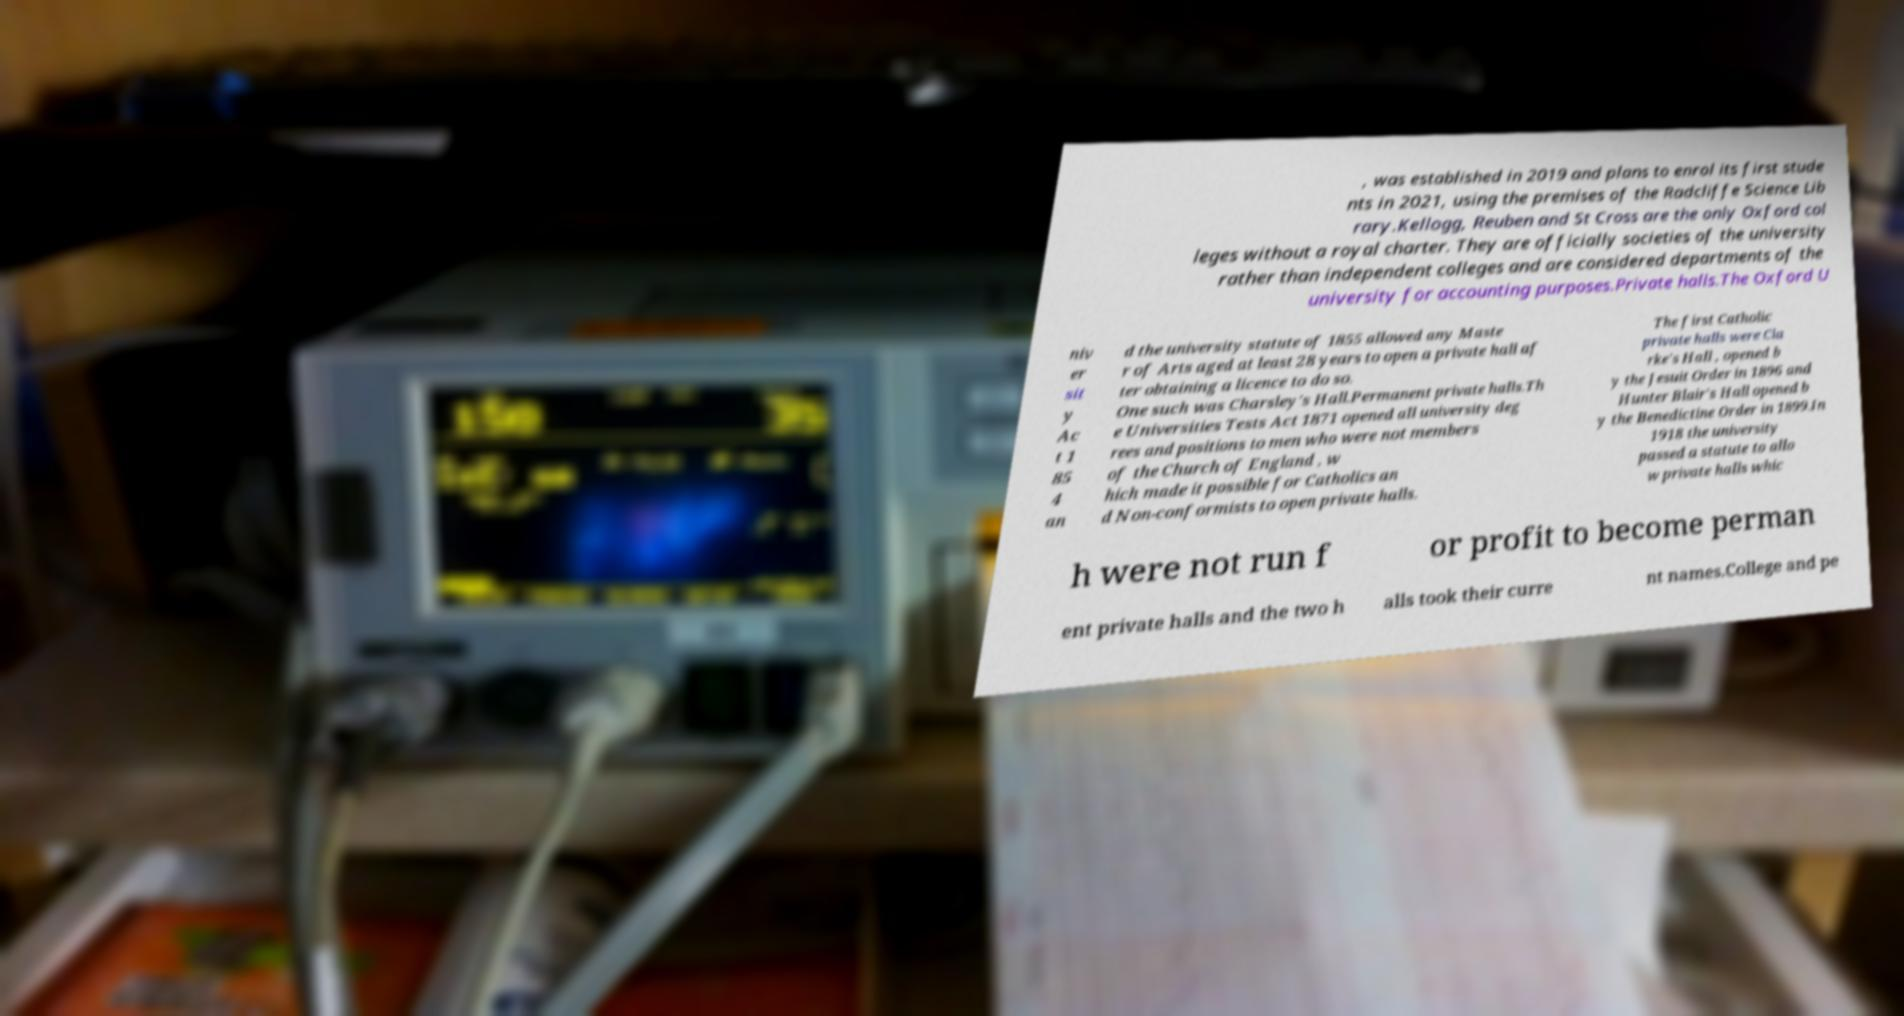Can you read and provide the text displayed in the image?This photo seems to have some interesting text. Can you extract and type it out for me? , was established in 2019 and plans to enrol its first stude nts in 2021, using the premises of the Radcliffe Science Lib rary.Kellogg, Reuben and St Cross are the only Oxford col leges without a royal charter. They are officially societies of the university rather than independent colleges and are considered departments of the university for accounting purposes.Private halls.The Oxford U niv er sit y Ac t 1 85 4 an d the university statute of 1855 allowed any Maste r of Arts aged at least 28 years to open a private hall af ter obtaining a licence to do so. One such was Charsley's Hall.Permanent private halls.Th e Universities Tests Act 1871 opened all university deg rees and positions to men who were not members of the Church of England , w hich made it possible for Catholics an d Non-conformists to open private halls. The first Catholic private halls were Cla rke's Hall , opened b y the Jesuit Order in 1896 and Hunter Blair's Hall opened b y the Benedictine Order in 1899.In 1918 the university passed a statute to allo w private halls whic h were not run f or profit to become perman ent private halls and the two h alls took their curre nt names.College and pe 